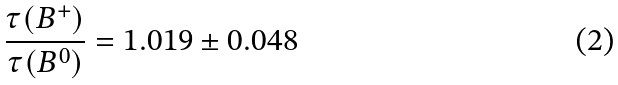Convert formula to latex. <formula><loc_0><loc_0><loc_500><loc_500>\frac { \tau ( B ^ { + } ) } { \tau ( B ^ { 0 } ) } = 1 . 0 1 9 \pm 0 . 0 4 8</formula> 